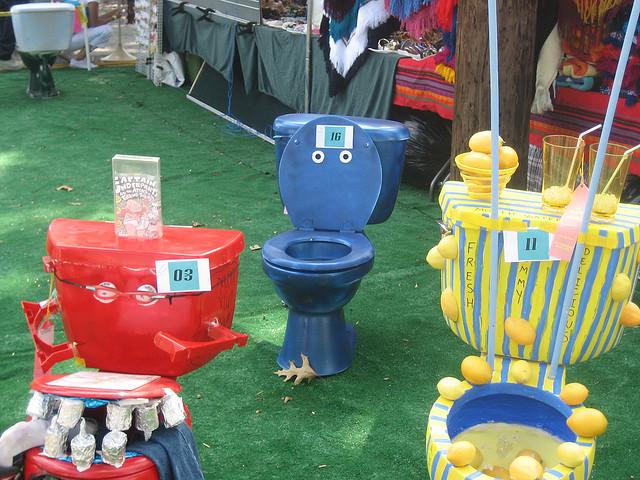What color is toilet 11?
Give a very brief answer. Yellow. What color is the one with stripes?
Be succinct. Yellow and blue. What room should number 03 be in?
Concise answer only. Bathroom. 